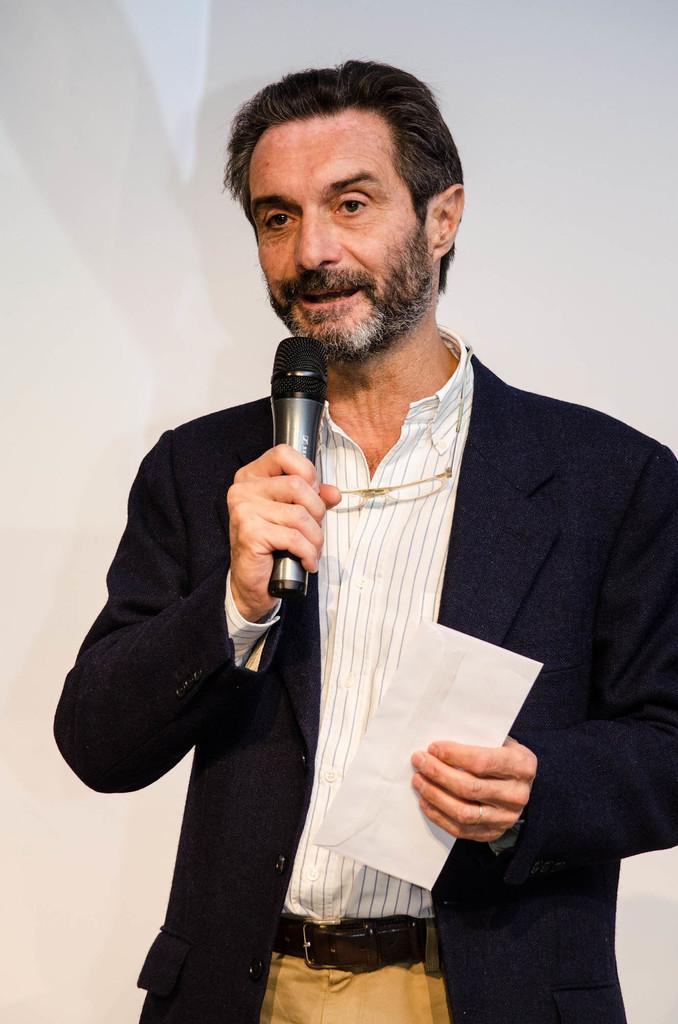What is the main subject of the image? There is a person standing in the center of the image. What is the person wearing? The person is wearing a suit. What is the person doing in the image? The person is speaking on a microphone. How many friends are visible in the image? There is no mention of friends in the image, so it cannot be determined how many are visible. What type of grape is being used as a prop in the image? There is no grape present in the image. 